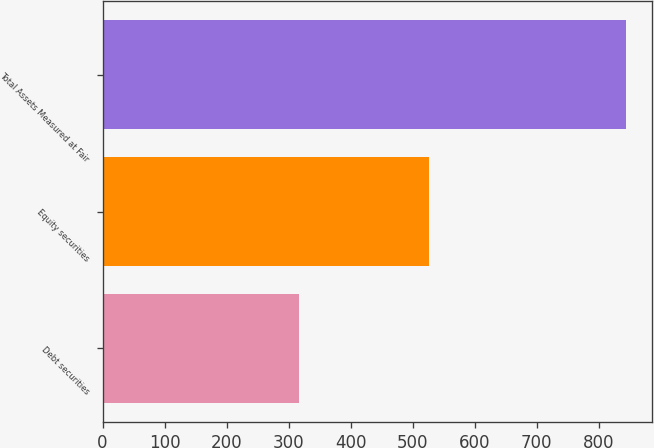Convert chart to OTSL. <chart><loc_0><loc_0><loc_500><loc_500><bar_chart><fcel>Debt securities<fcel>Equity securities<fcel>Total Assets Measured at Fair<nl><fcel>317.5<fcel>527<fcel>844.5<nl></chart> 